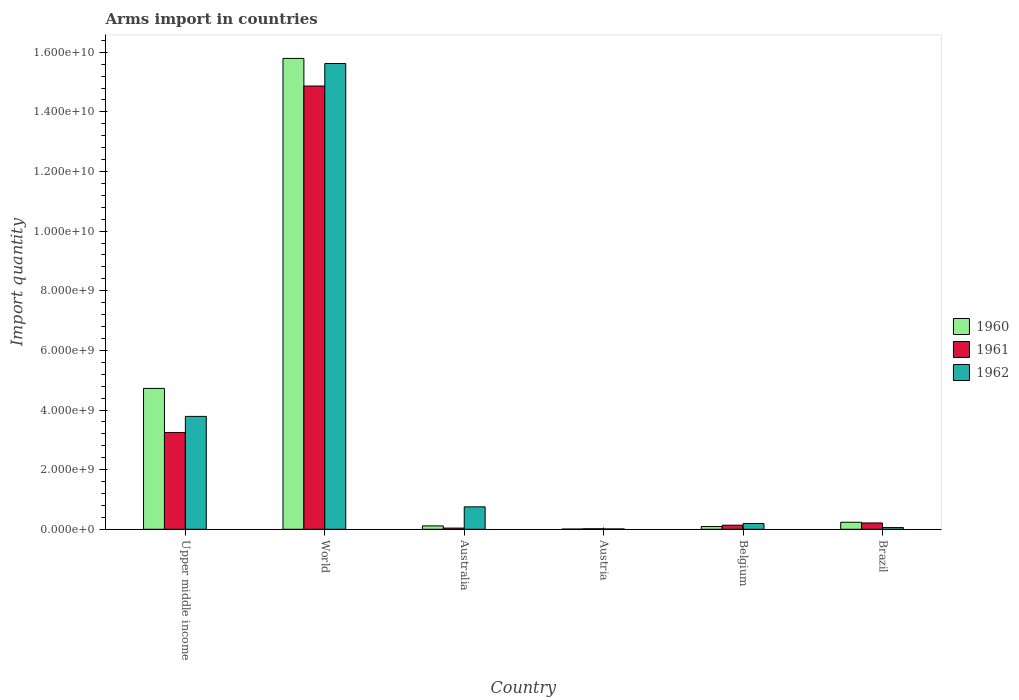How many different coloured bars are there?
Give a very brief answer. 3. How many groups of bars are there?
Make the answer very short. 6. How many bars are there on the 6th tick from the left?
Your response must be concise. 3. How many bars are there on the 4th tick from the right?
Offer a very short reply. 3. In how many cases, is the number of bars for a given country not equal to the number of legend labels?
Provide a short and direct response. 0. What is the total arms import in 1960 in Upper middle income?
Your response must be concise. 4.72e+09. Across all countries, what is the maximum total arms import in 1960?
Provide a succinct answer. 1.58e+1. Across all countries, what is the minimum total arms import in 1961?
Provide a short and direct response. 1.70e+07. In which country was the total arms import in 1961 maximum?
Offer a terse response. World. What is the total total arms import in 1962 in the graph?
Your response must be concise. 2.04e+1. What is the difference between the total arms import in 1961 in Australia and that in World?
Your answer should be compact. -1.48e+1. What is the difference between the total arms import in 1960 in Austria and the total arms import in 1961 in Belgium?
Keep it short and to the point. -1.30e+08. What is the average total arms import in 1962 per country?
Offer a very short reply. 3.40e+09. What is the difference between the total arms import of/in 1960 and total arms import of/in 1961 in World?
Provide a succinct answer. 9.26e+08. In how many countries, is the total arms import in 1962 greater than 10400000000?
Your answer should be compact. 1. What is the ratio of the total arms import in 1962 in Belgium to that in Upper middle income?
Make the answer very short. 0.05. What is the difference between the highest and the second highest total arms import in 1960?
Ensure brevity in your answer.  1.56e+1. What is the difference between the highest and the lowest total arms import in 1961?
Offer a very short reply. 1.48e+1. In how many countries, is the total arms import in 1960 greater than the average total arms import in 1960 taken over all countries?
Offer a terse response. 2. Is the sum of the total arms import in 1960 in Australia and Austria greater than the maximum total arms import in 1962 across all countries?
Your answer should be very brief. No. What does the 2nd bar from the left in World represents?
Your response must be concise. 1961. What does the 3rd bar from the right in Austria represents?
Ensure brevity in your answer.  1960. Is it the case that in every country, the sum of the total arms import in 1962 and total arms import in 1961 is greater than the total arms import in 1960?
Your answer should be very brief. Yes. How many bars are there?
Your answer should be very brief. 18. Are the values on the major ticks of Y-axis written in scientific E-notation?
Give a very brief answer. Yes. Does the graph contain grids?
Offer a very short reply. No. How many legend labels are there?
Your answer should be very brief. 3. What is the title of the graph?
Keep it short and to the point. Arms import in countries. Does "1989" appear as one of the legend labels in the graph?
Give a very brief answer. No. What is the label or title of the Y-axis?
Make the answer very short. Import quantity. What is the Import quantity in 1960 in Upper middle income?
Keep it short and to the point. 4.72e+09. What is the Import quantity of 1961 in Upper middle income?
Offer a terse response. 3.24e+09. What is the Import quantity in 1962 in Upper middle income?
Offer a very short reply. 3.79e+09. What is the Import quantity of 1960 in World?
Your answer should be compact. 1.58e+1. What is the Import quantity in 1961 in World?
Ensure brevity in your answer.  1.49e+1. What is the Import quantity of 1962 in World?
Keep it short and to the point. 1.56e+1. What is the Import quantity in 1960 in Australia?
Provide a succinct answer. 1.13e+08. What is the Import quantity in 1961 in Australia?
Offer a terse response. 4.00e+07. What is the Import quantity of 1962 in Australia?
Make the answer very short. 7.52e+08. What is the Import quantity in 1961 in Austria?
Keep it short and to the point. 1.70e+07. What is the Import quantity of 1962 in Austria?
Your answer should be compact. 1.10e+07. What is the Import quantity of 1960 in Belgium?
Offer a terse response. 9.20e+07. What is the Import quantity in 1961 in Belgium?
Offer a very short reply. 1.37e+08. What is the Import quantity of 1962 in Belgium?
Offer a terse response. 1.93e+08. What is the Import quantity of 1960 in Brazil?
Give a very brief answer. 2.36e+08. What is the Import quantity of 1961 in Brazil?
Your response must be concise. 2.12e+08. What is the Import quantity in 1962 in Brazil?
Your answer should be compact. 5.70e+07. Across all countries, what is the maximum Import quantity of 1960?
Provide a short and direct response. 1.58e+1. Across all countries, what is the maximum Import quantity in 1961?
Offer a terse response. 1.49e+1. Across all countries, what is the maximum Import quantity of 1962?
Your answer should be very brief. 1.56e+1. Across all countries, what is the minimum Import quantity in 1961?
Ensure brevity in your answer.  1.70e+07. Across all countries, what is the minimum Import quantity in 1962?
Your response must be concise. 1.10e+07. What is the total Import quantity of 1960 in the graph?
Your answer should be compact. 2.10e+1. What is the total Import quantity in 1961 in the graph?
Provide a succinct answer. 1.85e+1. What is the total Import quantity of 1962 in the graph?
Ensure brevity in your answer.  2.04e+1. What is the difference between the Import quantity in 1960 in Upper middle income and that in World?
Your answer should be very brief. -1.11e+1. What is the difference between the Import quantity in 1961 in Upper middle income and that in World?
Provide a succinct answer. -1.16e+1. What is the difference between the Import quantity of 1962 in Upper middle income and that in World?
Give a very brief answer. -1.18e+1. What is the difference between the Import quantity of 1960 in Upper middle income and that in Australia?
Make the answer very short. 4.61e+09. What is the difference between the Import quantity in 1961 in Upper middle income and that in Australia?
Your response must be concise. 3.20e+09. What is the difference between the Import quantity of 1962 in Upper middle income and that in Australia?
Keep it short and to the point. 3.03e+09. What is the difference between the Import quantity of 1960 in Upper middle income and that in Austria?
Make the answer very short. 4.72e+09. What is the difference between the Import quantity in 1961 in Upper middle income and that in Austria?
Offer a very short reply. 3.23e+09. What is the difference between the Import quantity of 1962 in Upper middle income and that in Austria?
Make the answer very short. 3.78e+09. What is the difference between the Import quantity of 1960 in Upper middle income and that in Belgium?
Offer a very short reply. 4.63e+09. What is the difference between the Import quantity of 1961 in Upper middle income and that in Belgium?
Give a very brief answer. 3.11e+09. What is the difference between the Import quantity in 1962 in Upper middle income and that in Belgium?
Make the answer very short. 3.59e+09. What is the difference between the Import quantity of 1960 in Upper middle income and that in Brazil?
Your answer should be very brief. 4.49e+09. What is the difference between the Import quantity in 1961 in Upper middle income and that in Brazil?
Your answer should be compact. 3.03e+09. What is the difference between the Import quantity in 1962 in Upper middle income and that in Brazil?
Make the answer very short. 3.73e+09. What is the difference between the Import quantity of 1960 in World and that in Australia?
Your answer should be very brief. 1.57e+1. What is the difference between the Import quantity of 1961 in World and that in Australia?
Your answer should be compact. 1.48e+1. What is the difference between the Import quantity in 1962 in World and that in Australia?
Give a very brief answer. 1.49e+1. What is the difference between the Import quantity of 1960 in World and that in Austria?
Keep it short and to the point. 1.58e+1. What is the difference between the Import quantity of 1961 in World and that in Austria?
Offer a very short reply. 1.48e+1. What is the difference between the Import quantity in 1962 in World and that in Austria?
Your answer should be very brief. 1.56e+1. What is the difference between the Import quantity in 1960 in World and that in Belgium?
Your response must be concise. 1.57e+1. What is the difference between the Import quantity of 1961 in World and that in Belgium?
Provide a succinct answer. 1.47e+1. What is the difference between the Import quantity in 1962 in World and that in Belgium?
Keep it short and to the point. 1.54e+1. What is the difference between the Import quantity in 1960 in World and that in Brazil?
Give a very brief answer. 1.56e+1. What is the difference between the Import quantity of 1961 in World and that in Brazil?
Provide a succinct answer. 1.47e+1. What is the difference between the Import quantity of 1962 in World and that in Brazil?
Offer a terse response. 1.56e+1. What is the difference between the Import quantity in 1960 in Australia and that in Austria?
Provide a succinct answer. 1.06e+08. What is the difference between the Import quantity in 1961 in Australia and that in Austria?
Offer a terse response. 2.30e+07. What is the difference between the Import quantity in 1962 in Australia and that in Austria?
Keep it short and to the point. 7.41e+08. What is the difference between the Import quantity of 1960 in Australia and that in Belgium?
Your answer should be compact. 2.10e+07. What is the difference between the Import quantity of 1961 in Australia and that in Belgium?
Your answer should be very brief. -9.70e+07. What is the difference between the Import quantity of 1962 in Australia and that in Belgium?
Make the answer very short. 5.59e+08. What is the difference between the Import quantity in 1960 in Australia and that in Brazil?
Ensure brevity in your answer.  -1.23e+08. What is the difference between the Import quantity of 1961 in Australia and that in Brazil?
Offer a terse response. -1.72e+08. What is the difference between the Import quantity of 1962 in Australia and that in Brazil?
Keep it short and to the point. 6.95e+08. What is the difference between the Import quantity in 1960 in Austria and that in Belgium?
Your answer should be compact. -8.50e+07. What is the difference between the Import quantity in 1961 in Austria and that in Belgium?
Your answer should be compact. -1.20e+08. What is the difference between the Import quantity of 1962 in Austria and that in Belgium?
Make the answer very short. -1.82e+08. What is the difference between the Import quantity in 1960 in Austria and that in Brazil?
Ensure brevity in your answer.  -2.29e+08. What is the difference between the Import quantity in 1961 in Austria and that in Brazil?
Ensure brevity in your answer.  -1.95e+08. What is the difference between the Import quantity of 1962 in Austria and that in Brazil?
Make the answer very short. -4.60e+07. What is the difference between the Import quantity of 1960 in Belgium and that in Brazil?
Keep it short and to the point. -1.44e+08. What is the difference between the Import quantity of 1961 in Belgium and that in Brazil?
Provide a succinct answer. -7.50e+07. What is the difference between the Import quantity of 1962 in Belgium and that in Brazil?
Your answer should be very brief. 1.36e+08. What is the difference between the Import quantity in 1960 in Upper middle income and the Import quantity in 1961 in World?
Your answer should be compact. -1.01e+1. What is the difference between the Import quantity of 1960 in Upper middle income and the Import quantity of 1962 in World?
Offer a very short reply. -1.09e+1. What is the difference between the Import quantity in 1961 in Upper middle income and the Import quantity in 1962 in World?
Keep it short and to the point. -1.24e+1. What is the difference between the Import quantity in 1960 in Upper middle income and the Import quantity in 1961 in Australia?
Ensure brevity in your answer.  4.68e+09. What is the difference between the Import quantity in 1960 in Upper middle income and the Import quantity in 1962 in Australia?
Ensure brevity in your answer.  3.97e+09. What is the difference between the Import quantity in 1961 in Upper middle income and the Import quantity in 1962 in Australia?
Give a very brief answer. 2.49e+09. What is the difference between the Import quantity in 1960 in Upper middle income and the Import quantity in 1961 in Austria?
Your answer should be very brief. 4.71e+09. What is the difference between the Import quantity in 1960 in Upper middle income and the Import quantity in 1962 in Austria?
Your answer should be very brief. 4.71e+09. What is the difference between the Import quantity in 1961 in Upper middle income and the Import quantity in 1962 in Austria?
Give a very brief answer. 3.23e+09. What is the difference between the Import quantity of 1960 in Upper middle income and the Import quantity of 1961 in Belgium?
Ensure brevity in your answer.  4.59e+09. What is the difference between the Import quantity in 1960 in Upper middle income and the Import quantity in 1962 in Belgium?
Provide a short and direct response. 4.53e+09. What is the difference between the Import quantity of 1961 in Upper middle income and the Import quantity of 1962 in Belgium?
Provide a succinct answer. 3.05e+09. What is the difference between the Import quantity of 1960 in Upper middle income and the Import quantity of 1961 in Brazil?
Your answer should be compact. 4.51e+09. What is the difference between the Import quantity of 1960 in Upper middle income and the Import quantity of 1962 in Brazil?
Keep it short and to the point. 4.67e+09. What is the difference between the Import quantity in 1961 in Upper middle income and the Import quantity in 1962 in Brazil?
Offer a very short reply. 3.19e+09. What is the difference between the Import quantity in 1960 in World and the Import quantity in 1961 in Australia?
Your answer should be compact. 1.58e+1. What is the difference between the Import quantity in 1960 in World and the Import quantity in 1962 in Australia?
Give a very brief answer. 1.50e+1. What is the difference between the Import quantity in 1961 in World and the Import quantity in 1962 in Australia?
Keep it short and to the point. 1.41e+1. What is the difference between the Import quantity of 1960 in World and the Import quantity of 1961 in Austria?
Keep it short and to the point. 1.58e+1. What is the difference between the Import quantity in 1960 in World and the Import quantity in 1962 in Austria?
Your response must be concise. 1.58e+1. What is the difference between the Import quantity of 1961 in World and the Import quantity of 1962 in Austria?
Your answer should be very brief. 1.49e+1. What is the difference between the Import quantity in 1960 in World and the Import quantity in 1961 in Belgium?
Keep it short and to the point. 1.57e+1. What is the difference between the Import quantity in 1960 in World and the Import quantity in 1962 in Belgium?
Your answer should be compact. 1.56e+1. What is the difference between the Import quantity in 1961 in World and the Import quantity in 1962 in Belgium?
Your answer should be very brief. 1.47e+1. What is the difference between the Import quantity in 1960 in World and the Import quantity in 1961 in Brazil?
Your answer should be very brief. 1.56e+1. What is the difference between the Import quantity of 1960 in World and the Import quantity of 1962 in Brazil?
Provide a succinct answer. 1.57e+1. What is the difference between the Import quantity of 1961 in World and the Import quantity of 1962 in Brazil?
Your answer should be compact. 1.48e+1. What is the difference between the Import quantity of 1960 in Australia and the Import quantity of 1961 in Austria?
Offer a terse response. 9.60e+07. What is the difference between the Import quantity in 1960 in Australia and the Import quantity in 1962 in Austria?
Give a very brief answer. 1.02e+08. What is the difference between the Import quantity of 1961 in Australia and the Import quantity of 1962 in Austria?
Provide a succinct answer. 2.90e+07. What is the difference between the Import quantity in 1960 in Australia and the Import quantity in 1961 in Belgium?
Offer a very short reply. -2.40e+07. What is the difference between the Import quantity in 1960 in Australia and the Import quantity in 1962 in Belgium?
Provide a short and direct response. -8.00e+07. What is the difference between the Import quantity in 1961 in Australia and the Import quantity in 1962 in Belgium?
Provide a succinct answer. -1.53e+08. What is the difference between the Import quantity of 1960 in Australia and the Import quantity of 1961 in Brazil?
Provide a short and direct response. -9.90e+07. What is the difference between the Import quantity of 1960 in Australia and the Import quantity of 1962 in Brazil?
Provide a short and direct response. 5.60e+07. What is the difference between the Import quantity in 1961 in Australia and the Import quantity in 1962 in Brazil?
Offer a very short reply. -1.70e+07. What is the difference between the Import quantity in 1960 in Austria and the Import quantity in 1961 in Belgium?
Your answer should be compact. -1.30e+08. What is the difference between the Import quantity of 1960 in Austria and the Import quantity of 1962 in Belgium?
Your answer should be very brief. -1.86e+08. What is the difference between the Import quantity in 1961 in Austria and the Import quantity in 1962 in Belgium?
Provide a succinct answer. -1.76e+08. What is the difference between the Import quantity in 1960 in Austria and the Import quantity in 1961 in Brazil?
Offer a very short reply. -2.05e+08. What is the difference between the Import quantity in 1960 in Austria and the Import quantity in 1962 in Brazil?
Give a very brief answer. -5.00e+07. What is the difference between the Import quantity in 1961 in Austria and the Import quantity in 1962 in Brazil?
Provide a succinct answer. -4.00e+07. What is the difference between the Import quantity of 1960 in Belgium and the Import quantity of 1961 in Brazil?
Your answer should be very brief. -1.20e+08. What is the difference between the Import quantity in 1960 in Belgium and the Import quantity in 1962 in Brazil?
Give a very brief answer. 3.50e+07. What is the difference between the Import quantity of 1961 in Belgium and the Import quantity of 1962 in Brazil?
Your answer should be very brief. 8.00e+07. What is the average Import quantity of 1960 per country?
Offer a terse response. 3.49e+09. What is the average Import quantity of 1961 per country?
Offer a very short reply. 3.09e+09. What is the average Import quantity in 1962 per country?
Offer a terse response. 3.40e+09. What is the difference between the Import quantity of 1960 and Import quantity of 1961 in Upper middle income?
Make the answer very short. 1.48e+09. What is the difference between the Import quantity of 1960 and Import quantity of 1962 in Upper middle income?
Offer a terse response. 9.39e+08. What is the difference between the Import quantity in 1961 and Import quantity in 1962 in Upper middle income?
Provide a short and direct response. -5.41e+08. What is the difference between the Import quantity of 1960 and Import quantity of 1961 in World?
Your answer should be very brief. 9.26e+08. What is the difference between the Import quantity of 1960 and Import quantity of 1962 in World?
Keep it short and to the point. 1.71e+08. What is the difference between the Import quantity in 1961 and Import quantity in 1962 in World?
Keep it short and to the point. -7.55e+08. What is the difference between the Import quantity of 1960 and Import quantity of 1961 in Australia?
Give a very brief answer. 7.30e+07. What is the difference between the Import quantity in 1960 and Import quantity in 1962 in Australia?
Your answer should be very brief. -6.39e+08. What is the difference between the Import quantity in 1961 and Import quantity in 1962 in Australia?
Your response must be concise. -7.12e+08. What is the difference between the Import quantity in 1960 and Import quantity in 1961 in Austria?
Provide a short and direct response. -1.00e+07. What is the difference between the Import quantity in 1961 and Import quantity in 1962 in Austria?
Give a very brief answer. 6.00e+06. What is the difference between the Import quantity in 1960 and Import quantity in 1961 in Belgium?
Your response must be concise. -4.50e+07. What is the difference between the Import quantity in 1960 and Import quantity in 1962 in Belgium?
Provide a succinct answer. -1.01e+08. What is the difference between the Import quantity in 1961 and Import quantity in 1962 in Belgium?
Keep it short and to the point. -5.60e+07. What is the difference between the Import quantity in 1960 and Import quantity in 1961 in Brazil?
Provide a short and direct response. 2.40e+07. What is the difference between the Import quantity in 1960 and Import quantity in 1962 in Brazil?
Your answer should be very brief. 1.79e+08. What is the difference between the Import quantity in 1961 and Import quantity in 1962 in Brazil?
Provide a succinct answer. 1.55e+08. What is the ratio of the Import quantity of 1960 in Upper middle income to that in World?
Ensure brevity in your answer.  0.3. What is the ratio of the Import quantity in 1961 in Upper middle income to that in World?
Keep it short and to the point. 0.22. What is the ratio of the Import quantity in 1962 in Upper middle income to that in World?
Ensure brevity in your answer.  0.24. What is the ratio of the Import quantity in 1960 in Upper middle income to that in Australia?
Your answer should be very brief. 41.81. What is the ratio of the Import quantity in 1961 in Upper middle income to that in Australia?
Provide a succinct answer. 81.12. What is the ratio of the Import quantity in 1962 in Upper middle income to that in Australia?
Give a very brief answer. 5.03. What is the ratio of the Import quantity in 1960 in Upper middle income to that in Austria?
Give a very brief answer. 675. What is the ratio of the Import quantity in 1961 in Upper middle income to that in Austria?
Give a very brief answer. 190.88. What is the ratio of the Import quantity of 1962 in Upper middle income to that in Austria?
Keep it short and to the point. 344.18. What is the ratio of the Import quantity in 1960 in Upper middle income to that in Belgium?
Provide a succinct answer. 51.36. What is the ratio of the Import quantity of 1961 in Upper middle income to that in Belgium?
Your answer should be very brief. 23.69. What is the ratio of the Import quantity in 1962 in Upper middle income to that in Belgium?
Your answer should be very brief. 19.62. What is the ratio of the Import quantity of 1960 in Upper middle income to that in Brazil?
Your response must be concise. 20.02. What is the ratio of the Import quantity in 1961 in Upper middle income to that in Brazil?
Your response must be concise. 15.31. What is the ratio of the Import quantity in 1962 in Upper middle income to that in Brazil?
Ensure brevity in your answer.  66.42. What is the ratio of the Import quantity of 1960 in World to that in Australia?
Give a very brief answer. 139.76. What is the ratio of the Import quantity in 1961 in World to that in Australia?
Keep it short and to the point. 371.68. What is the ratio of the Import quantity in 1962 in World to that in Australia?
Provide a short and direct response. 20.77. What is the ratio of the Import quantity in 1960 in World to that in Austria?
Give a very brief answer. 2256.14. What is the ratio of the Import quantity in 1961 in World to that in Austria?
Ensure brevity in your answer.  874.53. What is the ratio of the Import quantity of 1962 in World to that in Austria?
Give a very brief answer. 1420.18. What is the ratio of the Import quantity in 1960 in World to that in Belgium?
Keep it short and to the point. 171.66. What is the ratio of the Import quantity in 1961 in World to that in Belgium?
Offer a terse response. 108.52. What is the ratio of the Import quantity of 1962 in World to that in Belgium?
Provide a succinct answer. 80.94. What is the ratio of the Import quantity in 1960 in World to that in Brazil?
Provide a succinct answer. 66.92. What is the ratio of the Import quantity of 1961 in World to that in Brazil?
Your response must be concise. 70.13. What is the ratio of the Import quantity in 1962 in World to that in Brazil?
Give a very brief answer. 274.07. What is the ratio of the Import quantity of 1960 in Australia to that in Austria?
Give a very brief answer. 16.14. What is the ratio of the Import quantity in 1961 in Australia to that in Austria?
Your answer should be compact. 2.35. What is the ratio of the Import quantity in 1962 in Australia to that in Austria?
Give a very brief answer. 68.36. What is the ratio of the Import quantity of 1960 in Australia to that in Belgium?
Provide a short and direct response. 1.23. What is the ratio of the Import quantity of 1961 in Australia to that in Belgium?
Ensure brevity in your answer.  0.29. What is the ratio of the Import quantity in 1962 in Australia to that in Belgium?
Offer a terse response. 3.9. What is the ratio of the Import quantity of 1960 in Australia to that in Brazil?
Your answer should be compact. 0.48. What is the ratio of the Import quantity in 1961 in Australia to that in Brazil?
Provide a succinct answer. 0.19. What is the ratio of the Import quantity in 1962 in Australia to that in Brazil?
Provide a short and direct response. 13.19. What is the ratio of the Import quantity in 1960 in Austria to that in Belgium?
Your answer should be very brief. 0.08. What is the ratio of the Import quantity in 1961 in Austria to that in Belgium?
Your response must be concise. 0.12. What is the ratio of the Import quantity in 1962 in Austria to that in Belgium?
Offer a terse response. 0.06. What is the ratio of the Import quantity of 1960 in Austria to that in Brazil?
Your answer should be very brief. 0.03. What is the ratio of the Import quantity in 1961 in Austria to that in Brazil?
Offer a terse response. 0.08. What is the ratio of the Import quantity in 1962 in Austria to that in Brazil?
Offer a very short reply. 0.19. What is the ratio of the Import quantity in 1960 in Belgium to that in Brazil?
Provide a succinct answer. 0.39. What is the ratio of the Import quantity in 1961 in Belgium to that in Brazil?
Your answer should be compact. 0.65. What is the ratio of the Import quantity of 1962 in Belgium to that in Brazil?
Your response must be concise. 3.39. What is the difference between the highest and the second highest Import quantity of 1960?
Offer a very short reply. 1.11e+1. What is the difference between the highest and the second highest Import quantity in 1961?
Provide a succinct answer. 1.16e+1. What is the difference between the highest and the second highest Import quantity of 1962?
Offer a terse response. 1.18e+1. What is the difference between the highest and the lowest Import quantity of 1960?
Offer a very short reply. 1.58e+1. What is the difference between the highest and the lowest Import quantity of 1961?
Offer a very short reply. 1.48e+1. What is the difference between the highest and the lowest Import quantity of 1962?
Your answer should be very brief. 1.56e+1. 